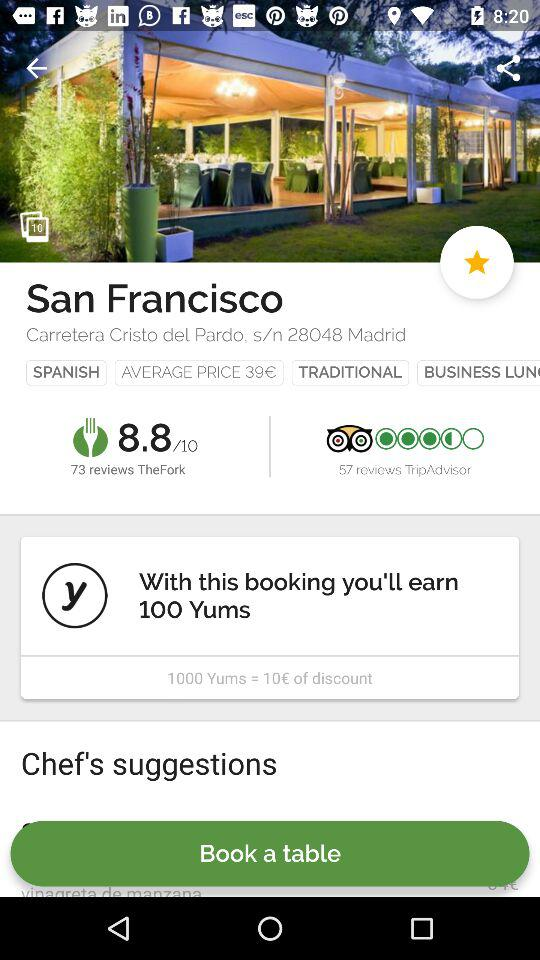How many Yums can I earn by booking? You can earn 100 Yums by booking. 